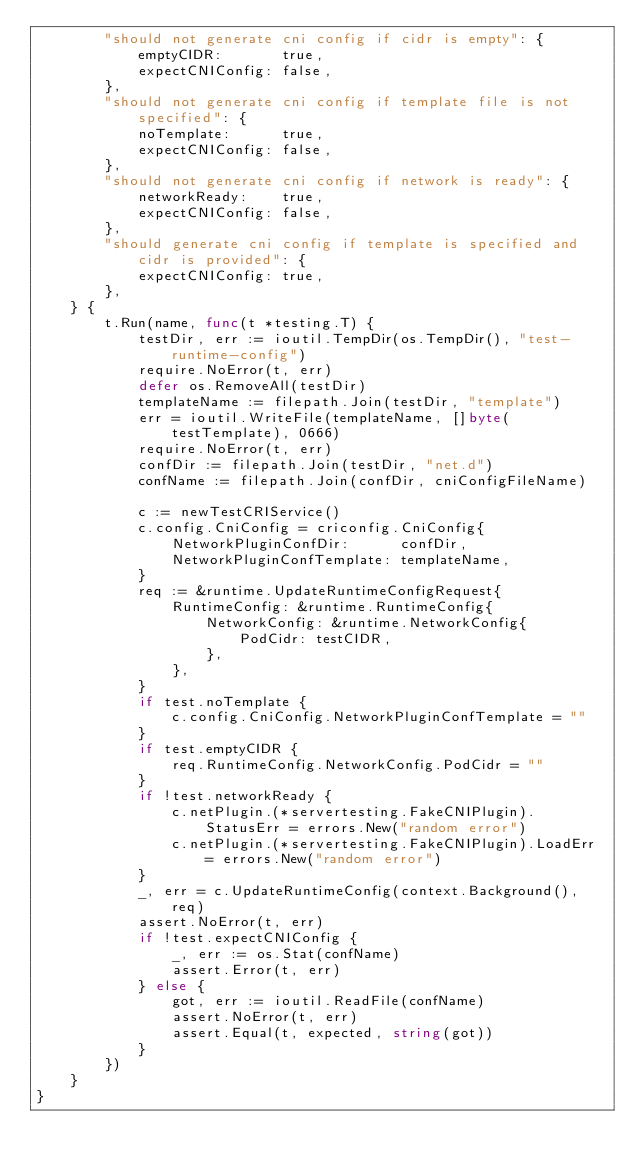Convert code to text. <code><loc_0><loc_0><loc_500><loc_500><_Go_>		"should not generate cni config if cidr is empty": {
			emptyCIDR:       true,
			expectCNIConfig: false,
		},
		"should not generate cni config if template file is not specified": {
			noTemplate:      true,
			expectCNIConfig: false,
		},
		"should not generate cni config if network is ready": {
			networkReady:    true,
			expectCNIConfig: false,
		},
		"should generate cni config if template is specified and cidr is provided": {
			expectCNIConfig: true,
		},
	} {
		t.Run(name, func(t *testing.T) {
			testDir, err := ioutil.TempDir(os.TempDir(), "test-runtime-config")
			require.NoError(t, err)
			defer os.RemoveAll(testDir)
			templateName := filepath.Join(testDir, "template")
			err = ioutil.WriteFile(templateName, []byte(testTemplate), 0666)
			require.NoError(t, err)
			confDir := filepath.Join(testDir, "net.d")
			confName := filepath.Join(confDir, cniConfigFileName)

			c := newTestCRIService()
			c.config.CniConfig = criconfig.CniConfig{
				NetworkPluginConfDir:      confDir,
				NetworkPluginConfTemplate: templateName,
			}
			req := &runtime.UpdateRuntimeConfigRequest{
				RuntimeConfig: &runtime.RuntimeConfig{
					NetworkConfig: &runtime.NetworkConfig{
						PodCidr: testCIDR,
					},
				},
			}
			if test.noTemplate {
				c.config.CniConfig.NetworkPluginConfTemplate = ""
			}
			if test.emptyCIDR {
				req.RuntimeConfig.NetworkConfig.PodCidr = ""
			}
			if !test.networkReady {
				c.netPlugin.(*servertesting.FakeCNIPlugin).StatusErr = errors.New("random error")
				c.netPlugin.(*servertesting.FakeCNIPlugin).LoadErr = errors.New("random error")
			}
			_, err = c.UpdateRuntimeConfig(context.Background(), req)
			assert.NoError(t, err)
			if !test.expectCNIConfig {
				_, err := os.Stat(confName)
				assert.Error(t, err)
			} else {
				got, err := ioutil.ReadFile(confName)
				assert.NoError(t, err)
				assert.Equal(t, expected, string(got))
			}
		})
	}
}
</code> 